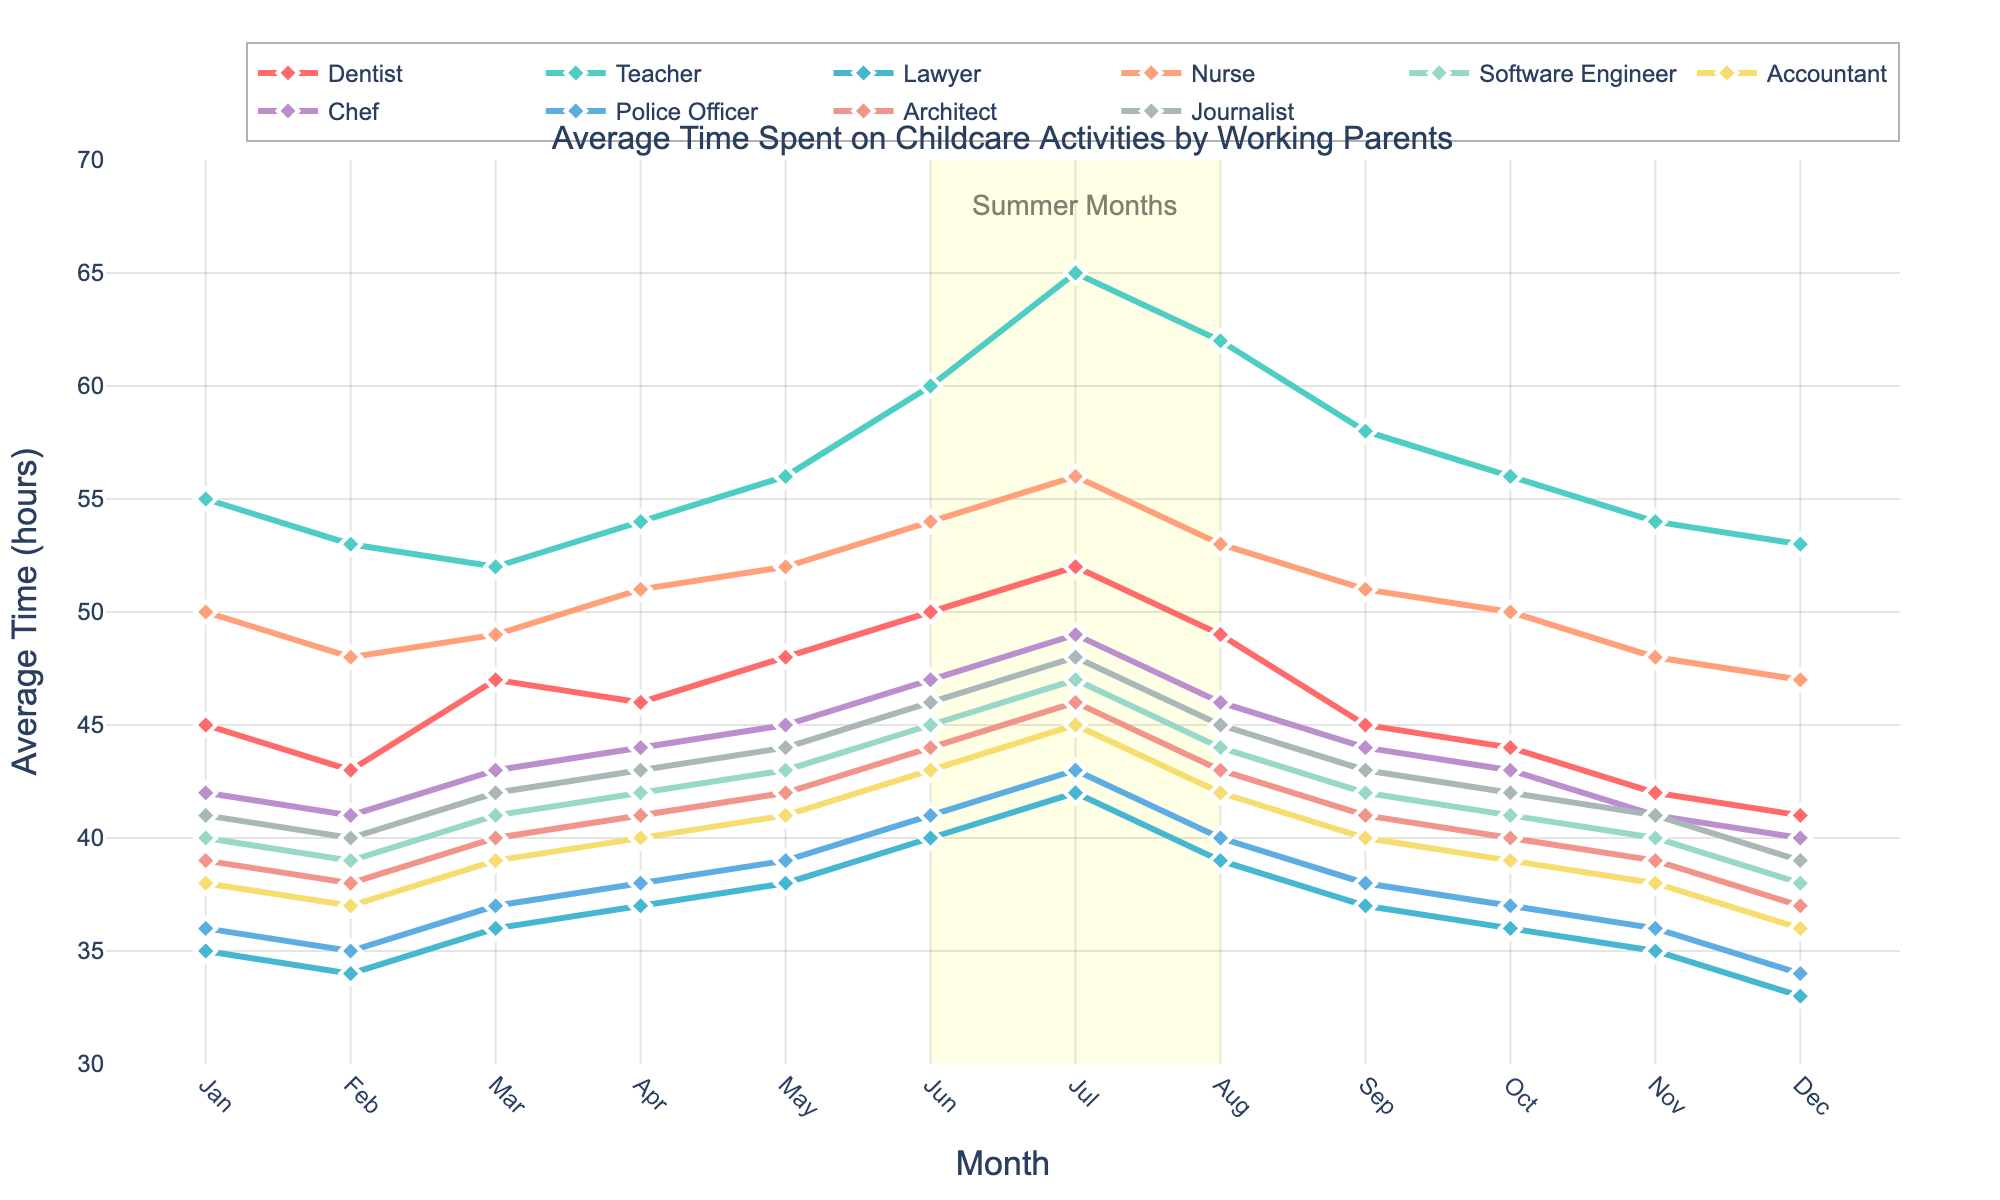What trend can be observed for the average time spent on childcare by teachers from January to December? The average time spent on childcare by teachers shows a generally increasing trend from January to July, peaking at 65 hours in July, and then decreases but remains relatively high toward the end of the year.
Answer: Generally increasing, peaking in July, then decreasing Which profession spends the most time on childcare activities during the summer months (June to August)? By examining the highlighted summer months, we can see that "Teacher" spends the most time on childcare activities, with the highest value at 65 hours in July.
Answer: Teacher Compare the average time spent on childcare activities by dentists and lawyers in April. Who spends more time, and by how much? In April, dentists spend 46 hours, while lawyers spend 37 hours on childcare activities. The difference is 46 - 37 = 9 hours.
Answer: Dentists, by 9 hours What is the combined time spent on childcare by nurses and software engineers in October? In October, nurses spend 50 hours, and software engineers spend 41 hours on childcare. The combined time is 50 + 41 = 91 hours.
Answer: 91 hours Identify the profession with the lowest average time spent on childcare in December. In December, the average times are 41 (Dentist), 53 (Teacher), 33 (Lawyer), 47 (Nurse), 38 (Software Engineer), 36 (Accountant), 40 (Chef), 34 (Police Officer), 37 (Architect), and 39 (Journalist). "Lawyer" has the lowest average time spent on childcare, with 33 hours.
Answer: Lawyer What is the average time spent on childcare by chefs and journalists in March? In March, chefs spend 43 hours, and journalists spend 42 hours on childcare. Their average time spent is (43 + 42) / 2 = 42.5 hours.
Answer: 42.5 hours During which month do architects spend the most time on childcare? By examining the data for architects, the month with the highest time spent on childcare is July, with 46 hours.
Answer: July What is the difference in the maximum average time spent between nurses and accountants in any month? The maximum average time spent by nurses is 56 hours in July, and for accountants, it is 45 hours in July. The difference is 56 - 45 = 11 hours.
Answer: 11 hours 